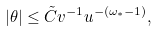<formula> <loc_0><loc_0><loc_500><loc_500>| \theta | \leq \tilde { C } v ^ { - 1 } u ^ { - ( \omega _ { * } - 1 ) } ,</formula> 